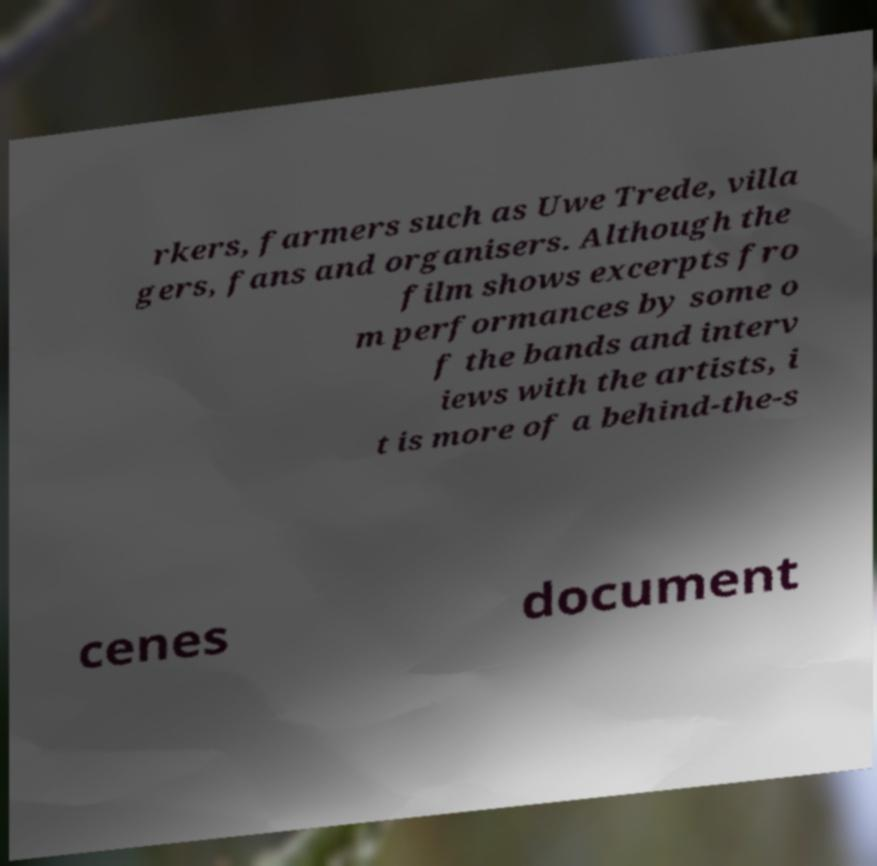Can you accurately transcribe the text from the provided image for me? rkers, farmers such as Uwe Trede, villa gers, fans and organisers. Although the film shows excerpts fro m performances by some o f the bands and interv iews with the artists, i t is more of a behind-the-s cenes document 